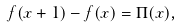<formula> <loc_0><loc_0><loc_500><loc_500>f ( x + 1 ) - f ( x ) = \Pi ( x ) ,</formula> 